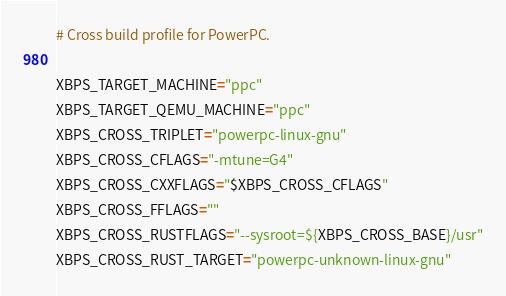Convert code to text. <code><loc_0><loc_0><loc_500><loc_500><_Bash_># Cross build profile for PowerPC.

XBPS_TARGET_MACHINE="ppc"
XBPS_TARGET_QEMU_MACHINE="ppc"
XBPS_CROSS_TRIPLET="powerpc-linux-gnu"
XBPS_CROSS_CFLAGS="-mtune=G4"
XBPS_CROSS_CXXFLAGS="$XBPS_CROSS_CFLAGS"
XBPS_CROSS_FFLAGS=""
XBPS_CROSS_RUSTFLAGS="--sysroot=${XBPS_CROSS_BASE}/usr"
XBPS_CROSS_RUST_TARGET="powerpc-unknown-linux-gnu"
</code> 